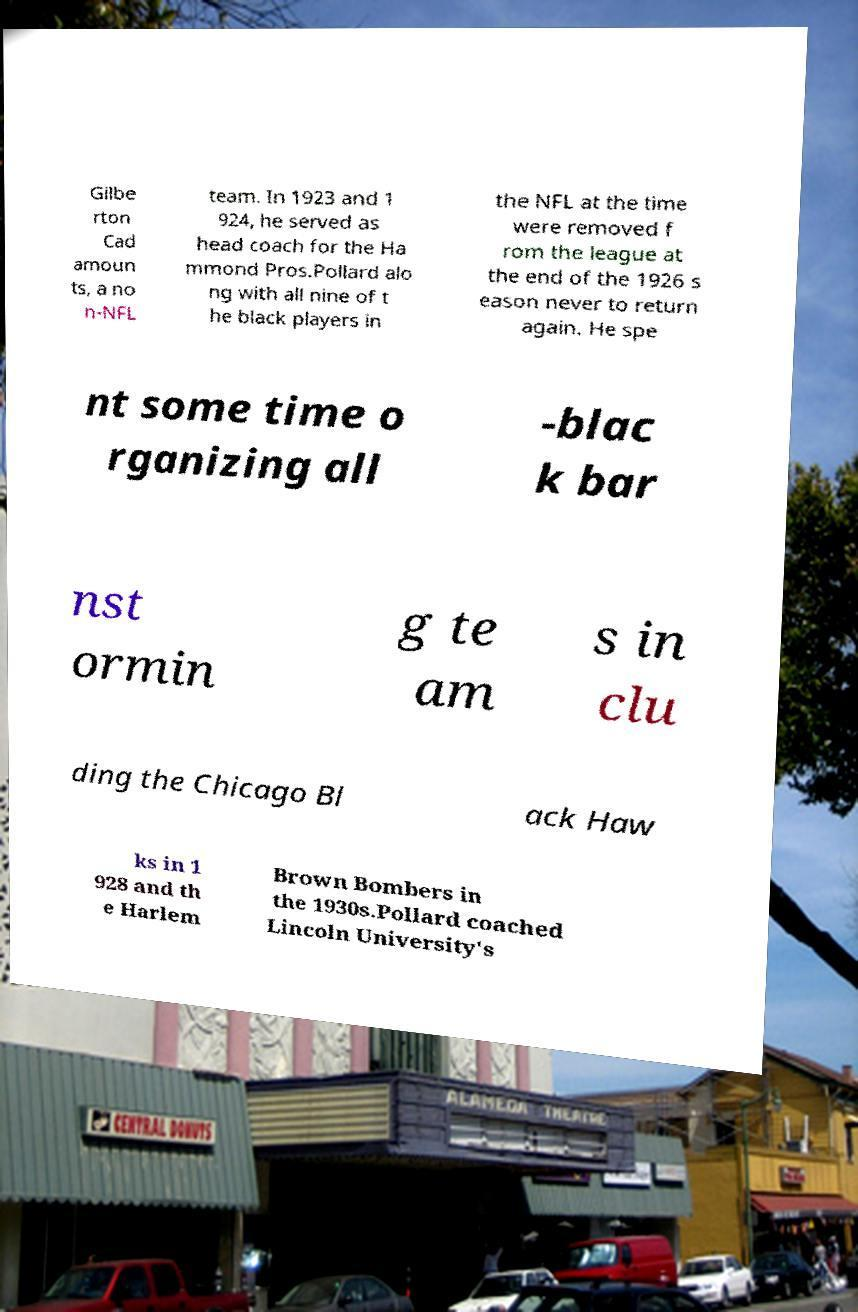What messages or text are displayed in this image? I need them in a readable, typed format. Gilbe rton Cad amoun ts, a no n-NFL team. In 1923 and 1 924, he served as head coach for the Ha mmond Pros.Pollard alo ng with all nine of t he black players in the NFL at the time were removed f rom the league at the end of the 1926 s eason never to return again. He spe nt some time o rganizing all -blac k bar nst ormin g te am s in clu ding the Chicago Bl ack Haw ks in 1 928 and th e Harlem Brown Bombers in the 1930s.Pollard coached Lincoln University's 